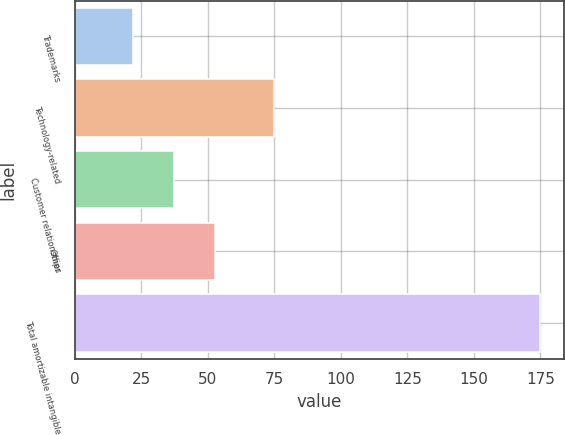Convert chart to OTSL. <chart><loc_0><loc_0><loc_500><loc_500><bar_chart><fcel>Trademarks<fcel>Technology-related<fcel>Customer relationships<fcel>Other<fcel>Total amortizable intangible<nl><fcel>22<fcel>75<fcel>37.3<fcel>52.6<fcel>175<nl></chart> 